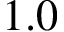Convert formula to latex. <formula><loc_0><loc_0><loc_500><loc_500>1 . 0</formula> 